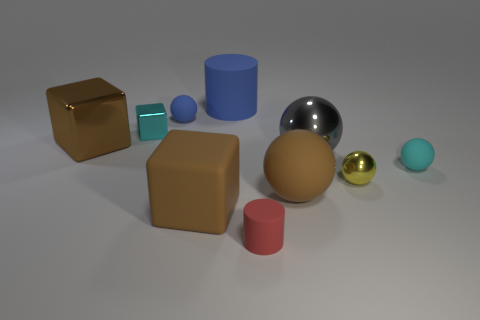Subtract 1 balls. How many balls are left? 4 Subtract all blocks. How many objects are left? 7 Add 7 large shiny balls. How many large shiny balls are left? 8 Add 4 small spheres. How many small spheres exist? 7 Subtract 0 brown cylinders. How many objects are left? 10 Subtract all green cylinders. Subtract all tiny yellow metal things. How many objects are left? 9 